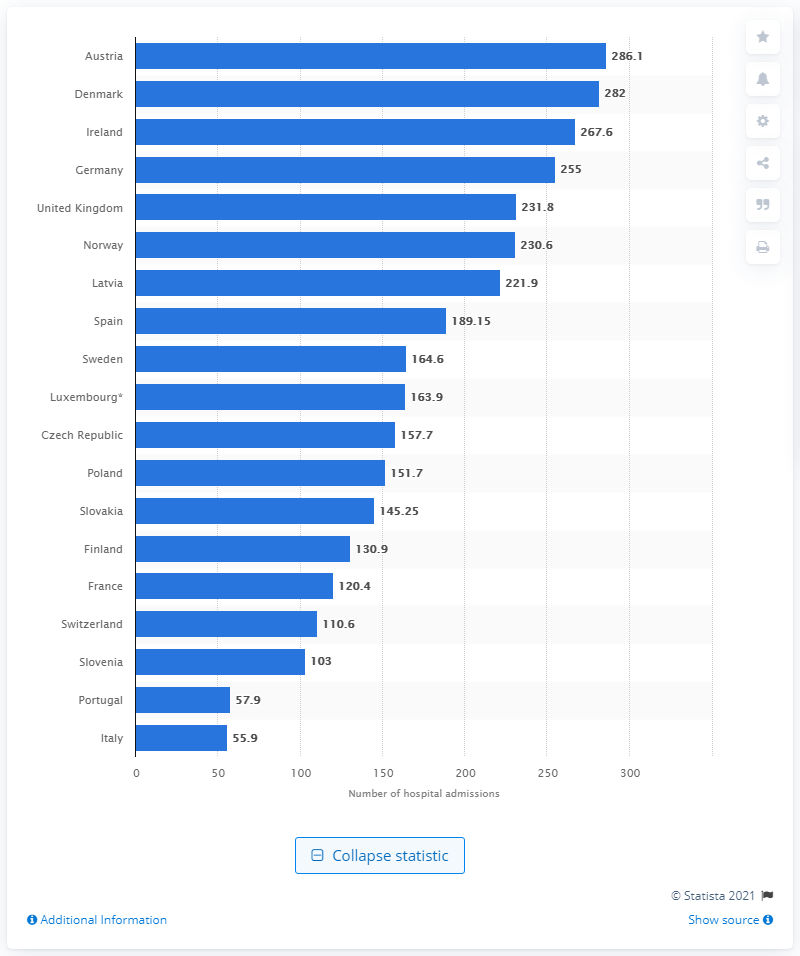Draw attention to some important aspects in this diagram. In 2015, Austria had 286.1 hospital admissions for chronic obstructive pulmonary disease (COPD) per 100,000 population. In 2015, the country with the highest number of hospital admissions for COPD was Austria. 